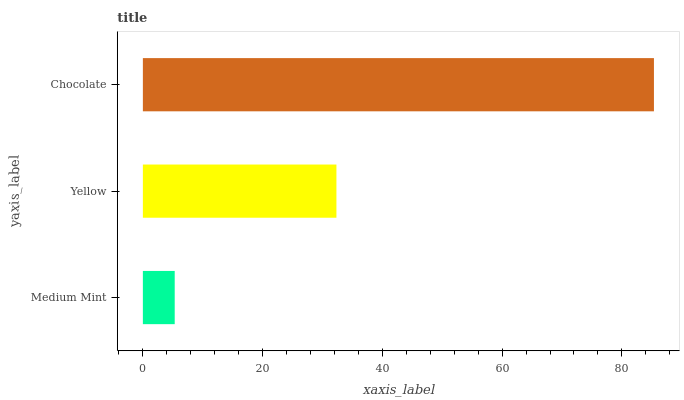Is Medium Mint the minimum?
Answer yes or no. Yes. Is Chocolate the maximum?
Answer yes or no. Yes. Is Yellow the minimum?
Answer yes or no. No. Is Yellow the maximum?
Answer yes or no. No. Is Yellow greater than Medium Mint?
Answer yes or no. Yes. Is Medium Mint less than Yellow?
Answer yes or no. Yes. Is Medium Mint greater than Yellow?
Answer yes or no. No. Is Yellow less than Medium Mint?
Answer yes or no. No. Is Yellow the high median?
Answer yes or no. Yes. Is Yellow the low median?
Answer yes or no. Yes. Is Medium Mint the high median?
Answer yes or no. No. Is Medium Mint the low median?
Answer yes or no. No. 